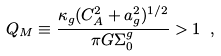Convert formula to latex. <formula><loc_0><loc_0><loc_500><loc_500>Q _ { M } \equiv \frac { \kappa _ { g } ( C _ { A } ^ { 2 } + a _ { g } ^ { 2 } ) ^ { 1 / 2 } } { \pi G \Sigma ^ { g } _ { 0 } } > 1 \ ,</formula> 